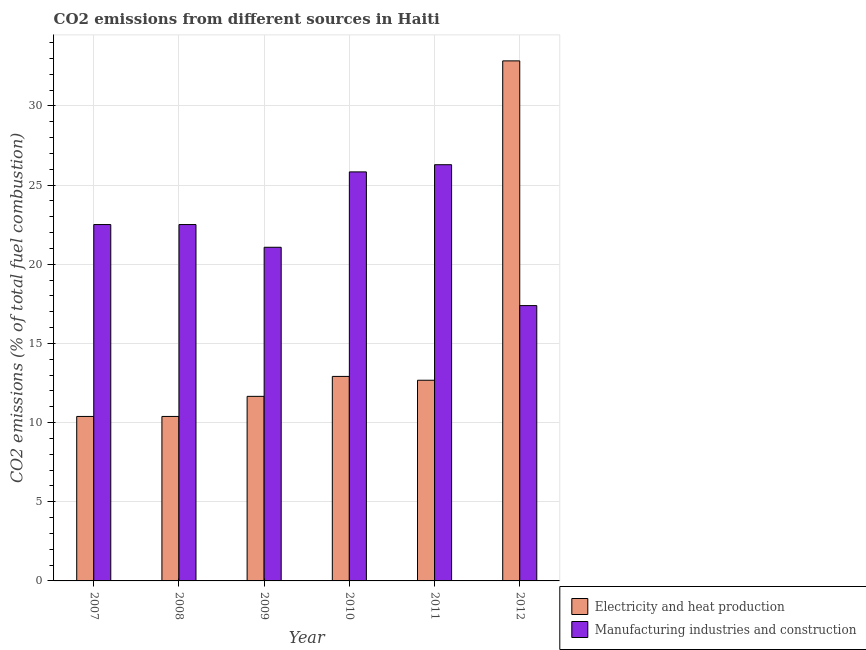How many groups of bars are there?
Give a very brief answer. 6. Are the number of bars per tick equal to the number of legend labels?
Offer a terse response. Yes. How many bars are there on the 6th tick from the left?
Your response must be concise. 2. What is the label of the 4th group of bars from the left?
Provide a short and direct response. 2010. What is the co2 emissions due to manufacturing industries in 2009?
Your response must be concise. 21.08. Across all years, what is the maximum co2 emissions due to manufacturing industries?
Your response must be concise. 26.29. Across all years, what is the minimum co2 emissions due to electricity and heat production?
Ensure brevity in your answer.  10.39. In which year was the co2 emissions due to manufacturing industries minimum?
Your answer should be compact. 2012. What is the total co2 emissions due to manufacturing industries in the graph?
Keep it short and to the point. 135.62. What is the difference between the co2 emissions due to manufacturing industries in 2009 and that in 2011?
Provide a succinct answer. -5.21. What is the difference between the co2 emissions due to manufacturing industries in 2011 and the co2 emissions due to electricity and heat production in 2008?
Your answer should be compact. 3.78. What is the average co2 emissions due to manufacturing industries per year?
Provide a succinct answer. 22.6. What is the ratio of the co2 emissions due to manufacturing industries in 2008 to that in 2010?
Make the answer very short. 0.87. Is the co2 emissions due to manufacturing industries in 2011 less than that in 2012?
Offer a terse response. No. What is the difference between the highest and the second highest co2 emissions due to manufacturing industries?
Provide a succinct answer. 0.45. What is the difference between the highest and the lowest co2 emissions due to manufacturing industries?
Give a very brief answer. 8.9. In how many years, is the co2 emissions due to electricity and heat production greater than the average co2 emissions due to electricity and heat production taken over all years?
Offer a terse response. 1. What does the 1st bar from the left in 2008 represents?
Make the answer very short. Electricity and heat production. What does the 2nd bar from the right in 2009 represents?
Make the answer very short. Electricity and heat production. Are all the bars in the graph horizontal?
Give a very brief answer. No. Are the values on the major ticks of Y-axis written in scientific E-notation?
Make the answer very short. No. Does the graph contain any zero values?
Your answer should be compact. No. Where does the legend appear in the graph?
Your answer should be very brief. Bottom right. How many legend labels are there?
Ensure brevity in your answer.  2. What is the title of the graph?
Offer a very short reply. CO2 emissions from different sources in Haiti. What is the label or title of the X-axis?
Make the answer very short. Year. What is the label or title of the Y-axis?
Provide a succinct answer. CO2 emissions (% of total fuel combustion). What is the CO2 emissions (% of total fuel combustion) of Electricity and heat production in 2007?
Keep it short and to the point. 10.39. What is the CO2 emissions (% of total fuel combustion) of Manufacturing industries and construction in 2007?
Keep it short and to the point. 22.51. What is the CO2 emissions (% of total fuel combustion) in Electricity and heat production in 2008?
Offer a very short reply. 10.39. What is the CO2 emissions (% of total fuel combustion) of Manufacturing industries and construction in 2008?
Offer a very short reply. 22.51. What is the CO2 emissions (% of total fuel combustion) of Electricity and heat production in 2009?
Provide a succinct answer. 11.66. What is the CO2 emissions (% of total fuel combustion) in Manufacturing industries and construction in 2009?
Give a very brief answer. 21.08. What is the CO2 emissions (% of total fuel combustion) in Electricity and heat production in 2010?
Your response must be concise. 12.92. What is the CO2 emissions (% of total fuel combustion) of Manufacturing industries and construction in 2010?
Your answer should be compact. 25.84. What is the CO2 emissions (% of total fuel combustion) of Electricity and heat production in 2011?
Your answer should be compact. 12.68. What is the CO2 emissions (% of total fuel combustion) in Manufacturing industries and construction in 2011?
Ensure brevity in your answer.  26.29. What is the CO2 emissions (% of total fuel combustion) in Electricity and heat production in 2012?
Your response must be concise. 32.85. What is the CO2 emissions (% of total fuel combustion) of Manufacturing industries and construction in 2012?
Ensure brevity in your answer.  17.39. Across all years, what is the maximum CO2 emissions (% of total fuel combustion) of Electricity and heat production?
Ensure brevity in your answer.  32.85. Across all years, what is the maximum CO2 emissions (% of total fuel combustion) of Manufacturing industries and construction?
Your answer should be compact. 26.29. Across all years, what is the minimum CO2 emissions (% of total fuel combustion) of Electricity and heat production?
Make the answer very short. 10.39. Across all years, what is the minimum CO2 emissions (% of total fuel combustion) of Manufacturing industries and construction?
Your answer should be very brief. 17.39. What is the total CO2 emissions (% of total fuel combustion) of Electricity and heat production in the graph?
Your answer should be very brief. 90.88. What is the total CO2 emissions (% of total fuel combustion) in Manufacturing industries and construction in the graph?
Your response must be concise. 135.62. What is the difference between the CO2 emissions (% of total fuel combustion) in Electricity and heat production in 2007 and that in 2009?
Make the answer very short. -1.27. What is the difference between the CO2 emissions (% of total fuel combustion) of Manufacturing industries and construction in 2007 and that in 2009?
Provide a succinct answer. 1.43. What is the difference between the CO2 emissions (% of total fuel combustion) of Electricity and heat production in 2007 and that in 2010?
Offer a very short reply. -2.53. What is the difference between the CO2 emissions (% of total fuel combustion) of Manufacturing industries and construction in 2007 and that in 2010?
Keep it short and to the point. -3.33. What is the difference between the CO2 emissions (% of total fuel combustion) of Electricity and heat production in 2007 and that in 2011?
Keep it short and to the point. -2.29. What is the difference between the CO2 emissions (% of total fuel combustion) in Manufacturing industries and construction in 2007 and that in 2011?
Keep it short and to the point. -3.78. What is the difference between the CO2 emissions (% of total fuel combustion) of Electricity and heat production in 2007 and that in 2012?
Your answer should be compact. -22.46. What is the difference between the CO2 emissions (% of total fuel combustion) of Manufacturing industries and construction in 2007 and that in 2012?
Your answer should be compact. 5.12. What is the difference between the CO2 emissions (% of total fuel combustion) in Electricity and heat production in 2008 and that in 2009?
Your answer should be compact. -1.27. What is the difference between the CO2 emissions (% of total fuel combustion) in Manufacturing industries and construction in 2008 and that in 2009?
Your answer should be compact. 1.43. What is the difference between the CO2 emissions (% of total fuel combustion) of Electricity and heat production in 2008 and that in 2010?
Your response must be concise. -2.53. What is the difference between the CO2 emissions (% of total fuel combustion) of Manufacturing industries and construction in 2008 and that in 2010?
Provide a short and direct response. -3.33. What is the difference between the CO2 emissions (% of total fuel combustion) in Electricity and heat production in 2008 and that in 2011?
Make the answer very short. -2.29. What is the difference between the CO2 emissions (% of total fuel combustion) of Manufacturing industries and construction in 2008 and that in 2011?
Give a very brief answer. -3.78. What is the difference between the CO2 emissions (% of total fuel combustion) in Electricity and heat production in 2008 and that in 2012?
Give a very brief answer. -22.46. What is the difference between the CO2 emissions (% of total fuel combustion) in Manufacturing industries and construction in 2008 and that in 2012?
Make the answer very short. 5.12. What is the difference between the CO2 emissions (% of total fuel combustion) in Electricity and heat production in 2009 and that in 2010?
Offer a very short reply. -1.26. What is the difference between the CO2 emissions (% of total fuel combustion) in Manufacturing industries and construction in 2009 and that in 2010?
Ensure brevity in your answer.  -4.76. What is the difference between the CO2 emissions (% of total fuel combustion) in Electricity and heat production in 2009 and that in 2011?
Provide a succinct answer. -1.02. What is the difference between the CO2 emissions (% of total fuel combustion) of Manufacturing industries and construction in 2009 and that in 2011?
Keep it short and to the point. -5.21. What is the difference between the CO2 emissions (% of total fuel combustion) of Electricity and heat production in 2009 and that in 2012?
Offer a terse response. -21.19. What is the difference between the CO2 emissions (% of total fuel combustion) of Manufacturing industries and construction in 2009 and that in 2012?
Your response must be concise. 3.68. What is the difference between the CO2 emissions (% of total fuel combustion) in Electricity and heat production in 2010 and that in 2011?
Make the answer very short. 0.24. What is the difference between the CO2 emissions (% of total fuel combustion) of Manufacturing industries and construction in 2010 and that in 2011?
Provide a short and direct response. -0.45. What is the difference between the CO2 emissions (% of total fuel combustion) of Electricity and heat production in 2010 and that in 2012?
Offer a terse response. -19.93. What is the difference between the CO2 emissions (% of total fuel combustion) in Manufacturing industries and construction in 2010 and that in 2012?
Keep it short and to the point. 8.45. What is the difference between the CO2 emissions (% of total fuel combustion) in Electricity and heat production in 2011 and that in 2012?
Keep it short and to the point. -20.17. What is the difference between the CO2 emissions (% of total fuel combustion) of Manufacturing industries and construction in 2011 and that in 2012?
Your answer should be compact. 8.9. What is the difference between the CO2 emissions (% of total fuel combustion) of Electricity and heat production in 2007 and the CO2 emissions (% of total fuel combustion) of Manufacturing industries and construction in 2008?
Keep it short and to the point. -12.12. What is the difference between the CO2 emissions (% of total fuel combustion) in Electricity and heat production in 2007 and the CO2 emissions (% of total fuel combustion) in Manufacturing industries and construction in 2009?
Make the answer very short. -10.69. What is the difference between the CO2 emissions (% of total fuel combustion) in Electricity and heat production in 2007 and the CO2 emissions (% of total fuel combustion) in Manufacturing industries and construction in 2010?
Keep it short and to the point. -15.45. What is the difference between the CO2 emissions (% of total fuel combustion) of Electricity and heat production in 2007 and the CO2 emissions (% of total fuel combustion) of Manufacturing industries and construction in 2011?
Make the answer very short. -15.9. What is the difference between the CO2 emissions (% of total fuel combustion) of Electricity and heat production in 2007 and the CO2 emissions (% of total fuel combustion) of Manufacturing industries and construction in 2012?
Give a very brief answer. -7. What is the difference between the CO2 emissions (% of total fuel combustion) of Electricity and heat production in 2008 and the CO2 emissions (% of total fuel combustion) of Manufacturing industries and construction in 2009?
Keep it short and to the point. -10.69. What is the difference between the CO2 emissions (% of total fuel combustion) of Electricity and heat production in 2008 and the CO2 emissions (% of total fuel combustion) of Manufacturing industries and construction in 2010?
Your answer should be compact. -15.45. What is the difference between the CO2 emissions (% of total fuel combustion) of Electricity and heat production in 2008 and the CO2 emissions (% of total fuel combustion) of Manufacturing industries and construction in 2011?
Offer a terse response. -15.9. What is the difference between the CO2 emissions (% of total fuel combustion) of Electricity and heat production in 2008 and the CO2 emissions (% of total fuel combustion) of Manufacturing industries and construction in 2012?
Make the answer very short. -7. What is the difference between the CO2 emissions (% of total fuel combustion) of Electricity and heat production in 2009 and the CO2 emissions (% of total fuel combustion) of Manufacturing industries and construction in 2010?
Provide a short and direct response. -14.18. What is the difference between the CO2 emissions (% of total fuel combustion) in Electricity and heat production in 2009 and the CO2 emissions (% of total fuel combustion) in Manufacturing industries and construction in 2011?
Keep it short and to the point. -14.63. What is the difference between the CO2 emissions (% of total fuel combustion) of Electricity and heat production in 2009 and the CO2 emissions (% of total fuel combustion) of Manufacturing industries and construction in 2012?
Offer a terse response. -5.73. What is the difference between the CO2 emissions (% of total fuel combustion) of Electricity and heat production in 2010 and the CO2 emissions (% of total fuel combustion) of Manufacturing industries and construction in 2011?
Ensure brevity in your answer.  -13.37. What is the difference between the CO2 emissions (% of total fuel combustion) of Electricity and heat production in 2010 and the CO2 emissions (% of total fuel combustion) of Manufacturing industries and construction in 2012?
Give a very brief answer. -4.47. What is the difference between the CO2 emissions (% of total fuel combustion) in Electricity and heat production in 2011 and the CO2 emissions (% of total fuel combustion) in Manufacturing industries and construction in 2012?
Your answer should be very brief. -4.72. What is the average CO2 emissions (% of total fuel combustion) in Electricity and heat production per year?
Provide a short and direct response. 15.15. What is the average CO2 emissions (% of total fuel combustion) of Manufacturing industries and construction per year?
Ensure brevity in your answer.  22.6. In the year 2007, what is the difference between the CO2 emissions (% of total fuel combustion) of Electricity and heat production and CO2 emissions (% of total fuel combustion) of Manufacturing industries and construction?
Your response must be concise. -12.12. In the year 2008, what is the difference between the CO2 emissions (% of total fuel combustion) of Electricity and heat production and CO2 emissions (% of total fuel combustion) of Manufacturing industries and construction?
Make the answer very short. -12.12. In the year 2009, what is the difference between the CO2 emissions (% of total fuel combustion) in Electricity and heat production and CO2 emissions (% of total fuel combustion) in Manufacturing industries and construction?
Provide a succinct answer. -9.42. In the year 2010, what is the difference between the CO2 emissions (% of total fuel combustion) in Electricity and heat production and CO2 emissions (% of total fuel combustion) in Manufacturing industries and construction?
Your answer should be compact. -12.92. In the year 2011, what is the difference between the CO2 emissions (% of total fuel combustion) in Electricity and heat production and CO2 emissions (% of total fuel combustion) in Manufacturing industries and construction?
Your answer should be very brief. -13.62. In the year 2012, what is the difference between the CO2 emissions (% of total fuel combustion) of Electricity and heat production and CO2 emissions (% of total fuel combustion) of Manufacturing industries and construction?
Offer a terse response. 15.46. What is the ratio of the CO2 emissions (% of total fuel combustion) in Manufacturing industries and construction in 2007 to that in 2008?
Offer a very short reply. 1. What is the ratio of the CO2 emissions (% of total fuel combustion) in Electricity and heat production in 2007 to that in 2009?
Provide a short and direct response. 0.89. What is the ratio of the CO2 emissions (% of total fuel combustion) of Manufacturing industries and construction in 2007 to that in 2009?
Your answer should be compact. 1.07. What is the ratio of the CO2 emissions (% of total fuel combustion) of Electricity and heat production in 2007 to that in 2010?
Provide a short and direct response. 0.8. What is the ratio of the CO2 emissions (% of total fuel combustion) in Manufacturing industries and construction in 2007 to that in 2010?
Your response must be concise. 0.87. What is the ratio of the CO2 emissions (% of total fuel combustion) in Electricity and heat production in 2007 to that in 2011?
Your response must be concise. 0.82. What is the ratio of the CO2 emissions (% of total fuel combustion) of Manufacturing industries and construction in 2007 to that in 2011?
Your answer should be compact. 0.86. What is the ratio of the CO2 emissions (% of total fuel combustion) in Electricity and heat production in 2007 to that in 2012?
Ensure brevity in your answer.  0.32. What is the ratio of the CO2 emissions (% of total fuel combustion) of Manufacturing industries and construction in 2007 to that in 2012?
Provide a short and direct response. 1.29. What is the ratio of the CO2 emissions (% of total fuel combustion) in Electricity and heat production in 2008 to that in 2009?
Your answer should be compact. 0.89. What is the ratio of the CO2 emissions (% of total fuel combustion) in Manufacturing industries and construction in 2008 to that in 2009?
Your answer should be compact. 1.07. What is the ratio of the CO2 emissions (% of total fuel combustion) in Electricity and heat production in 2008 to that in 2010?
Your answer should be compact. 0.8. What is the ratio of the CO2 emissions (% of total fuel combustion) of Manufacturing industries and construction in 2008 to that in 2010?
Offer a very short reply. 0.87. What is the ratio of the CO2 emissions (% of total fuel combustion) of Electricity and heat production in 2008 to that in 2011?
Your answer should be compact. 0.82. What is the ratio of the CO2 emissions (% of total fuel combustion) in Manufacturing industries and construction in 2008 to that in 2011?
Your answer should be very brief. 0.86. What is the ratio of the CO2 emissions (% of total fuel combustion) in Electricity and heat production in 2008 to that in 2012?
Make the answer very short. 0.32. What is the ratio of the CO2 emissions (% of total fuel combustion) of Manufacturing industries and construction in 2008 to that in 2012?
Keep it short and to the point. 1.29. What is the ratio of the CO2 emissions (% of total fuel combustion) of Electricity and heat production in 2009 to that in 2010?
Ensure brevity in your answer.  0.9. What is the ratio of the CO2 emissions (% of total fuel combustion) of Manufacturing industries and construction in 2009 to that in 2010?
Make the answer very short. 0.82. What is the ratio of the CO2 emissions (% of total fuel combustion) in Electricity and heat production in 2009 to that in 2011?
Offer a terse response. 0.92. What is the ratio of the CO2 emissions (% of total fuel combustion) of Manufacturing industries and construction in 2009 to that in 2011?
Make the answer very short. 0.8. What is the ratio of the CO2 emissions (% of total fuel combustion) of Electricity and heat production in 2009 to that in 2012?
Provide a succinct answer. 0.35. What is the ratio of the CO2 emissions (% of total fuel combustion) in Manufacturing industries and construction in 2009 to that in 2012?
Your answer should be very brief. 1.21. What is the ratio of the CO2 emissions (% of total fuel combustion) in Electricity and heat production in 2010 to that in 2011?
Give a very brief answer. 1.02. What is the ratio of the CO2 emissions (% of total fuel combustion) of Manufacturing industries and construction in 2010 to that in 2011?
Offer a terse response. 0.98. What is the ratio of the CO2 emissions (% of total fuel combustion) of Electricity and heat production in 2010 to that in 2012?
Offer a terse response. 0.39. What is the ratio of the CO2 emissions (% of total fuel combustion) of Manufacturing industries and construction in 2010 to that in 2012?
Your response must be concise. 1.49. What is the ratio of the CO2 emissions (% of total fuel combustion) in Electricity and heat production in 2011 to that in 2012?
Give a very brief answer. 0.39. What is the ratio of the CO2 emissions (% of total fuel combustion) in Manufacturing industries and construction in 2011 to that in 2012?
Provide a short and direct response. 1.51. What is the difference between the highest and the second highest CO2 emissions (% of total fuel combustion) of Electricity and heat production?
Provide a short and direct response. 19.93. What is the difference between the highest and the second highest CO2 emissions (% of total fuel combustion) in Manufacturing industries and construction?
Your response must be concise. 0.45. What is the difference between the highest and the lowest CO2 emissions (% of total fuel combustion) in Electricity and heat production?
Your answer should be very brief. 22.46. What is the difference between the highest and the lowest CO2 emissions (% of total fuel combustion) in Manufacturing industries and construction?
Your answer should be compact. 8.9. 